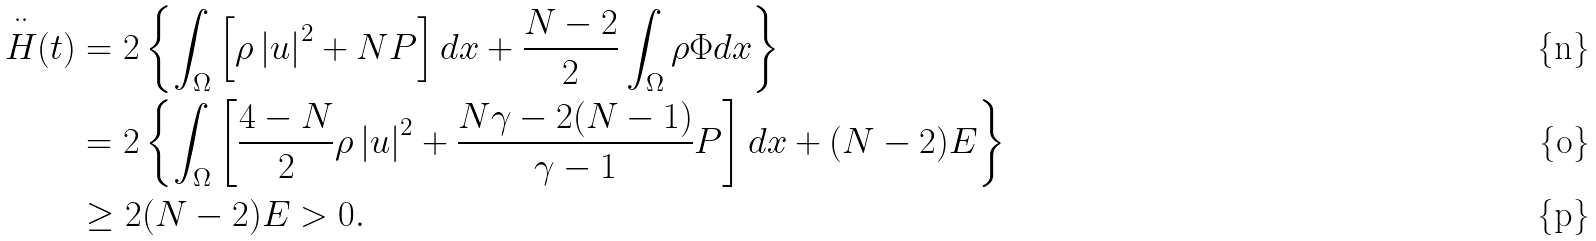<formula> <loc_0><loc_0><loc_500><loc_500>\overset { \cdot \cdot } { H } ( t ) & = 2 \left \{ \int _ { \Omega } \left [ \rho \left | u \right | ^ { 2 } + N P \right ] d x + \frac { N - 2 } { 2 } \int _ { \Omega } \rho \Phi d x \right \} \\ & = 2 \left \{ \int _ { \Omega } \left [ \frac { 4 - N } { 2 } \rho \left | u \right | ^ { 2 } + \frac { N \gamma - 2 ( N - 1 ) } { \gamma - 1 } P \right ] d x + ( N - 2 ) E \right \} \\ & \geq 2 ( N - 2 ) E > 0 .</formula> 